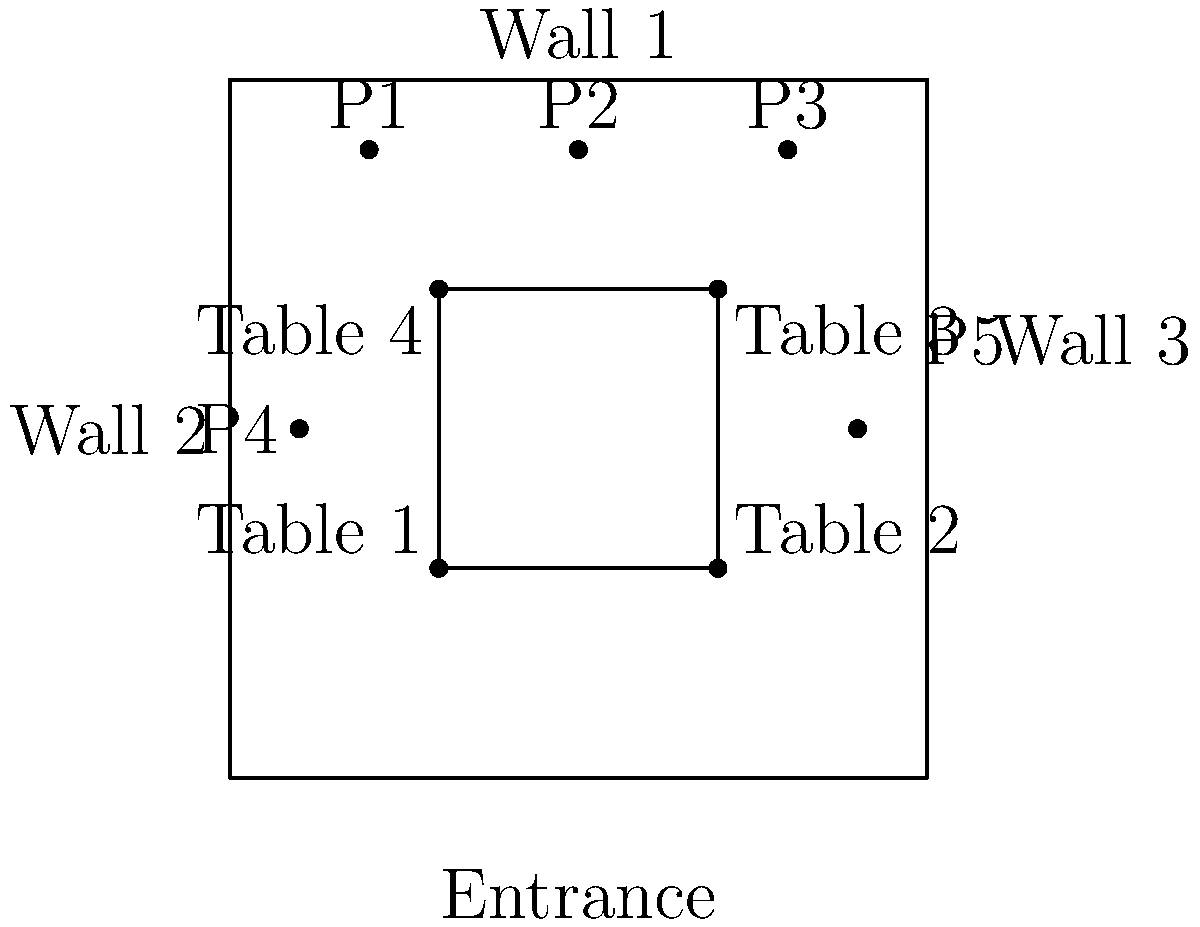As a restaurateur looking to maximize the impact of an athlete's promotional poster, which location would provide the best visibility from all dining tables in your restaurant? To determine the best location for the promotional athlete poster, we need to consider the visibility from all four tables in the dining area. Let's analyze each potential location:

1. P1 (top-left): Visible from Tables 1 and 4, partially visible from Table 2, not visible from Table 3.
2. P2 (top-center): Visible from all four tables, offering a clear line of sight.
3. P3 (top-right): Visible from Tables 2 and 3, partially visible from Table 1, not visible from Table 4.
4. P4 (left-center): Visible from Tables 1 and 4, partially visible from Tables 2 and 3.
5. P5 (right-center): Visible from Tables 2 and 3, partially visible from Tables 1 and 4.

The best location should maximize visibility from all tables while considering the entrance for initial impact. P2 (top-center) offers the following advantages:

1. Central position on Wall 1, providing a clear line of sight from all four tables.
2. Visible immediately upon entering the restaurant, creating a strong first impression.
3. Balanced visibility, ensuring no table has a significantly better or worse view than others.

This placement aligns with the restaurateur's goal of leveraging the athlete's brand for maximum exposure and marketing impact.
Answer: P2 (top-center) 